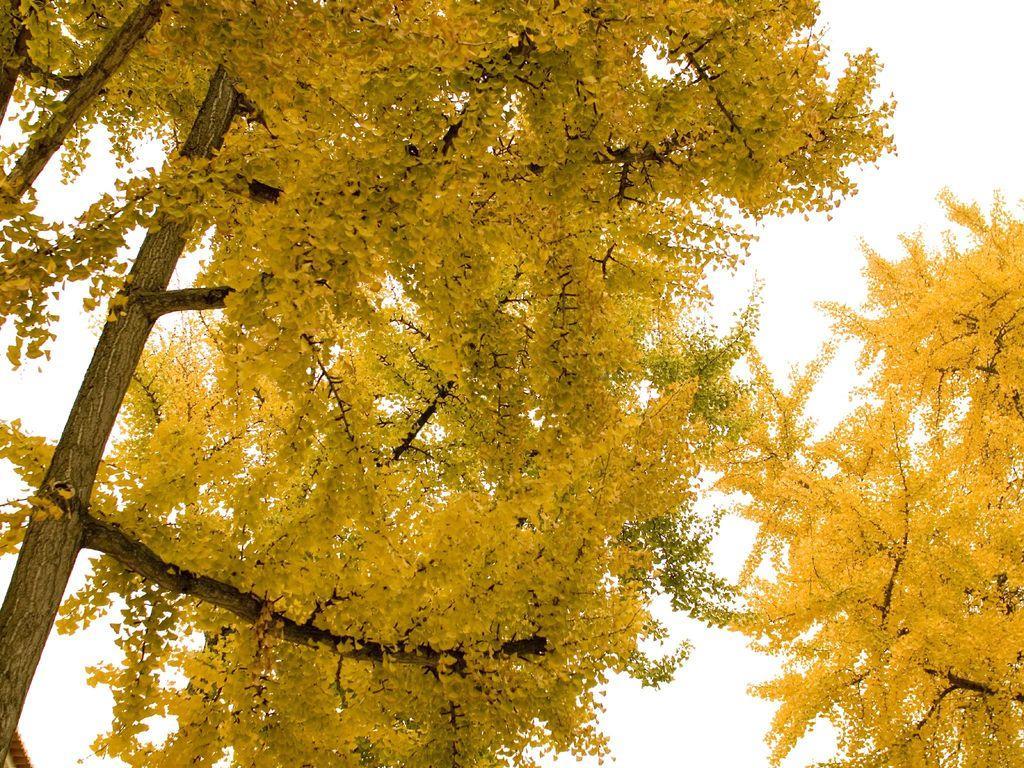In one or two sentences, can you explain what this image depicts? In this image I can see two trees which are yellow in color and I can see the white colored background. 